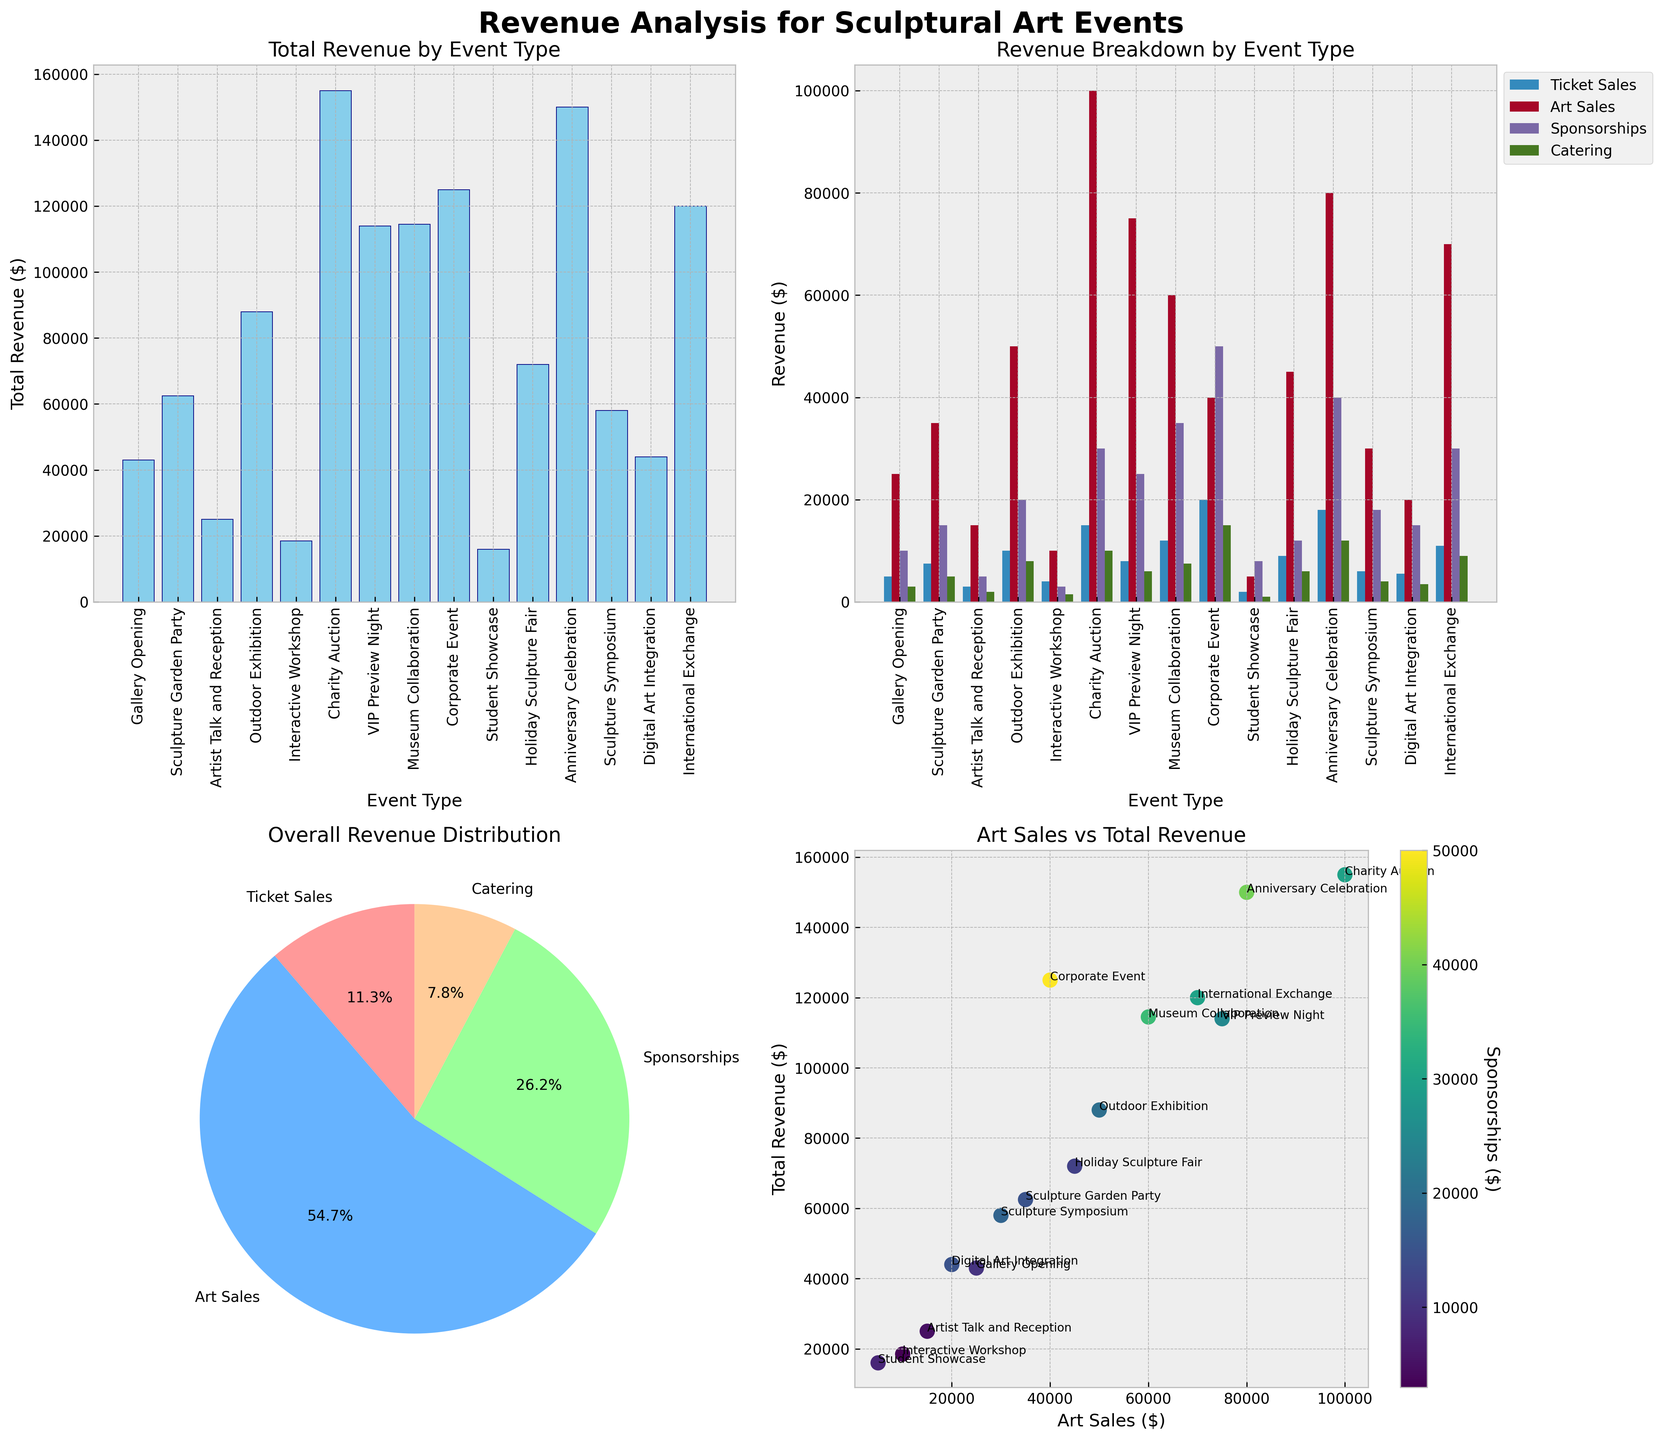Which event type generates the highest total revenue? The first subplot shows total revenue by event type. The tallest bar corresponds to the Charity Auction event.
Answer: Charity Auction What's the difference in total revenue between the Holiday Sculpture Fair and the Sculpture Symposium? The first subplot shows that the Holiday Sculpture Fair has a total revenue of $72,000, whereas the Sculpture Symposium has $58,000. The difference is $72,000 - $58,000 = $14,000.
Answer: $14,000 Which event type has the highest art sales? By referring to the second subplot, the highest value in the "Art Sales" category is for the Charity Auction event.
Answer: Charity Auction How does the total revenue from the Museum Collaboration compare with the Corporate Event? The first subplot shows that the Museum Collaboration has a total revenue of $114,500, while the Corporate Event has $125,000. The Corporate Event has higher total revenue.
Answer: Corporate Event What percentage of the overall revenue distribution comes from Sponsorships? The pie chart in the third subplot shows the overall revenue distribution. The value for Sponsorships is labeled, and by adding up the labels, Sponsorships account for 30.8%.
Answer: 30.8% Which event types feature in the scatter plot for Art Sales vs. Total Revenue with Art Sales over $50,000? The fourth subplot shows the scatter plot. The points with Art Sales over $50,000 are for VIP Preview Night, Museum Collaboration, and Charity Auction events.
Answer: VIP Preview Night, Museum Collaboration, Charity Auction Which category contributes the most to the total revenue of Interactive Workshop events? In the second subplot, the bar for Interactive Workshop shows that "Art Sales" contributes the most to its total revenue.
Answer: Art Sales How much higher is the total revenue for the Anniversary Celebration compared to the VIP Preview Night? The first subplot shows that the Anniversary Celebration has $150,000 in total revenue and the VIP Preview Night has $114,000. The difference is $150,000 - $114,000 = $36,000.
Answer: $36,000 What is the relationship between Sponsorship amounts and Total Revenue based on the scatter plot? In the scatter plot, points with higher Sponsorship amounts tend to also show higher Total Revenue, indicating a positive correlation.
Answer: Positive correlation 